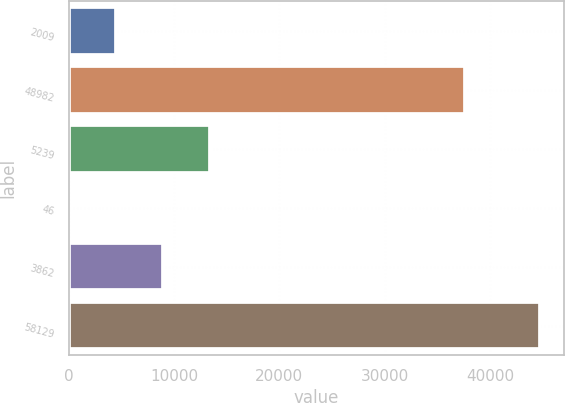Convert chart. <chart><loc_0><loc_0><loc_500><loc_500><bar_chart><fcel>2009<fcel>48982<fcel>5239<fcel>46<fcel>3862<fcel>58129<nl><fcel>4509.7<fcel>37657<fcel>13451.1<fcel>39<fcel>8980.4<fcel>44746<nl></chart> 